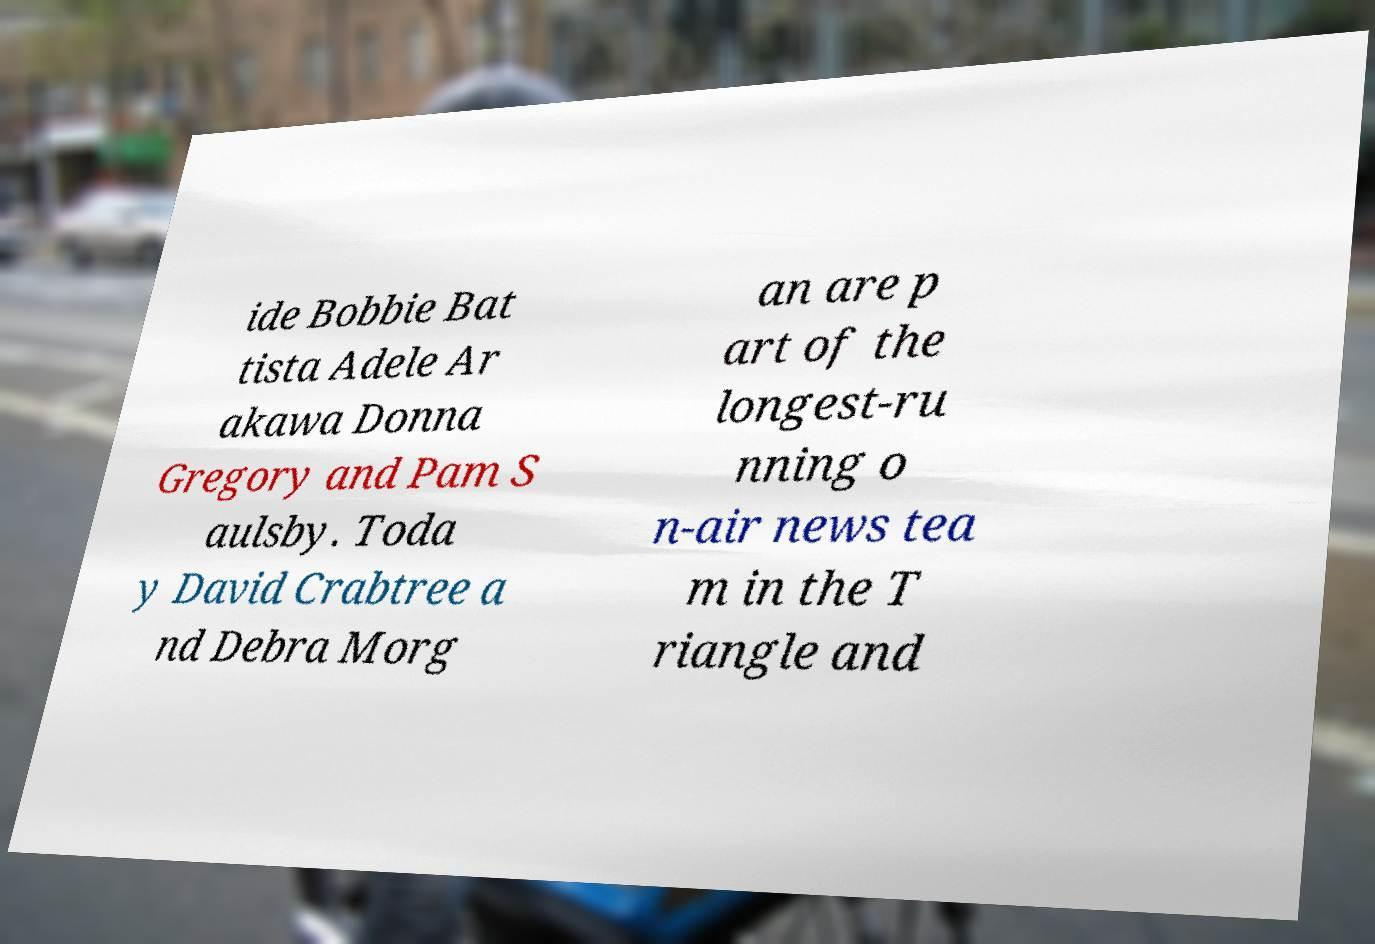For documentation purposes, I need the text within this image transcribed. Could you provide that? ide Bobbie Bat tista Adele Ar akawa Donna Gregory and Pam S aulsby. Toda y David Crabtree a nd Debra Morg an are p art of the longest-ru nning o n-air news tea m in the T riangle and 